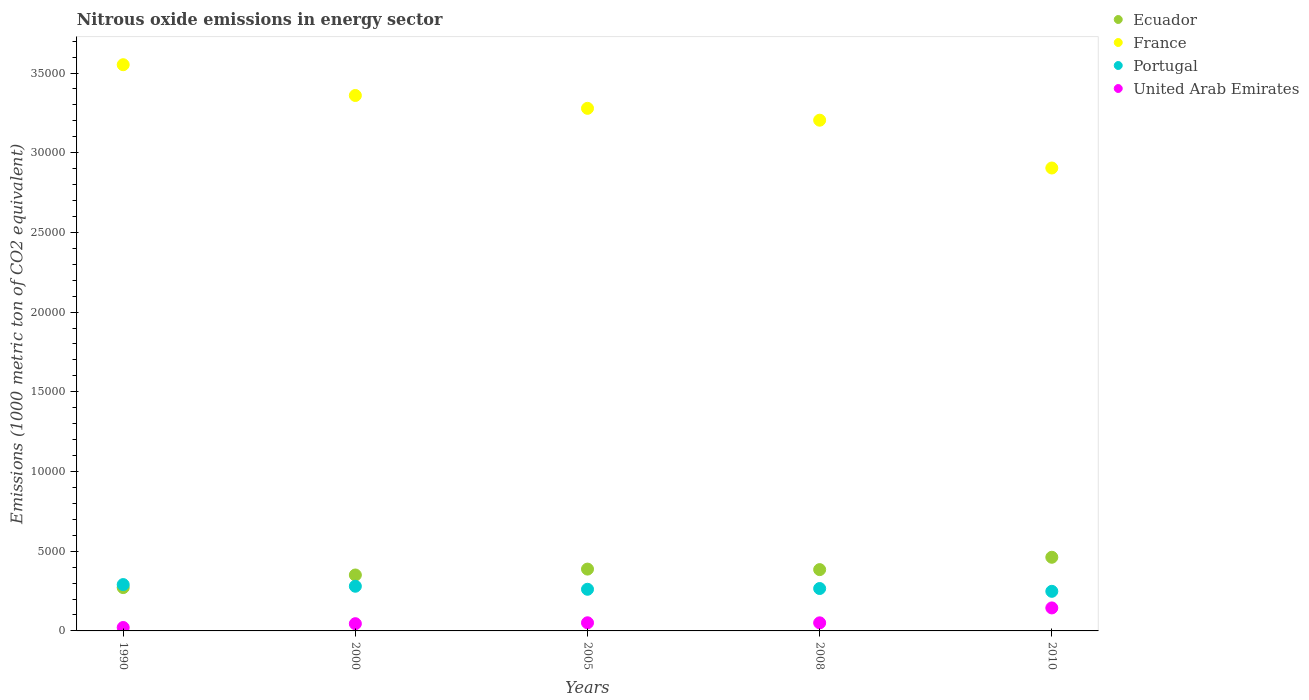What is the amount of nitrous oxide emitted in Ecuador in 2000?
Your answer should be compact. 3508.3. Across all years, what is the maximum amount of nitrous oxide emitted in Ecuador?
Offer a very short reply. 4620.6. Across all years, what is the minimum amount of nitrous oxide emitted in Ecuador?
Give a very brief answer. 2718.5. In which year was the amount of nitrous oxide emitted in France maximum?
Give a very brief answer. 1990. In which year was the amount of nitrous oxide emitted in Ecuador minimum?
Offer a terse response. 1990. What is the total amount of nitrous oxide emitted in France in the graph?
Your answer should be compact. 1.63e+05. What is the difference between the amount of nitrous oxide emitted in United Arab Emirates in 2005 and that in 2008?
Give a very brief answer. 2.5. What is the difference between the amount of nitrous oxide emitted in United Arab Emirates in 2000 and the amount of nitrous oxide emitted in France in 2008?
Provide a short and direct response. -3.16e+04. What is the average amount of nitrous oxide emitted in United Arab Emirates per year?
Offer a very short reply. 625.74. In the year 2005, what is the difference between the amount of nitrous oxide emitted in France and amount of nitrous oxide emitted in United Arab Emirates?
Make the answer very short. 3.23e+04. In how many years, is the amount of nitrous oxide emitted in Portugal greater than 5000 1000 metric ton?
Give a very brief answer. 0. What is the ratio of the amount of nitrous oxide emitted in France in 2005 to that in 2010?
Your answer should be compact. 1.13. What is the difference between the highest and the second highest amount of nitrous oxide emitted in Ecuador?
Your answer should be very brief. 742.1. What is the difference between the highest and the lowest amount of nitrous oxide emitted in Ecuador?
Give a very brief answer. 1902.1. Does the amount of nitrous oxide emitted in Ecuador monotonically increase over the years?
Keep it short and to the point. No. Is the amount of nitrous oxide emitted in Portugal strictly less than the amount of nitrous oxide emitted in United Arab Emirates over the years?
Your response must be concise. No. How many years are there in the graph?
Make the answer very short. 5. What is the difference between two consecutive major ticks on the Y-axis?
Give a very brief answer. 5000. Are the values on the major ticks of Y-axis written in scientific E-notation?
Keep it short and to the point. No. Does the graph contain any zero values?
Give a very brief answer. No. Does the graph contain grids?
Keep it short and to the point. No. Where does the legend appear in the graph?
Ensure brevity in your answer.  Top right. What is the title of the graph?
Give a very brief answer. Nitrous oxide emissions in energy sector. What is the label or title of the X-axis?
Ensure brevity in your answer.  Years. What is the label or title of the Y-axis?
Your answer should be compact. Emissions (1000 metric ton of CO2 equivalent). What is the Emissions (1000 metric ton of CO2 equivalent) in Ecuador in 1990?
Your answer should be compact. 2718.5. What is the Emissions (1000 metric ton of CO2 equivalent) in France in 1990?
Keep it short and to the point. 3.55e+04. What is the Emissions (1000 metric ton of CO2 equivalent) of Portugal in 1990?
Provide a succinct answer. 2907.5. What is the Emissions (1000 metric ton of CO2 equivalent) of United Arab Emirates in 1990?
Your answer should be very brief. 214.5. What is the Emissions (1000 metric ton of CO2 equivalent) of Ecuador in 2000?
Offer a terse response. 3508.3. What is the Emissions (1000 metric ton of CO2 equivalent) in France in 2000?
Ensure brevity in your answer.  3.36e+04. What is the Emissions (1000 metric ton of CO2 equivalent) of Portugal in 2000?
Offer a very short reply. 2802.4. What is the Emissions (1000 metric ton of CO2 equivalent) of United Arab Emirates in 2000?
Provide a short and direct response. 453.6. What is the Emissions (1000 metric ton of CO2 equivalent) in Ecuador in 2005?
Offer a terse response. 3878.5. What is the Emissions (1000 metric ton of CO2 equivalent) in France in 2005?
Keep it short and to the point. 3.28e+04. What is the Emissions (1000 metric ton of CO2 equivalent) of Portugal in 2005?
Make the answer very short. 2612.4. What is the Emissions (1000 metric ton of CO2 equivalent) in United Arab Emirates in 2005?
Keep it short and to the point. 510.2. What is the Emissions (1000 metric ton of CO2 equivalent) in Ecuador in 2008?
Your answer should be compact. 3846. What is the Emissions (1000 metric ton of CO2 equivalent) in France in 2008?
Give a very brief answer. 3.20e+04. What is the Emissions (1000 metric ton of CO2 equivalent) of Portugal in 2008?
Make the answer very short. 2660.2. What is the Emissions (1000 metric ton of CO2 equivalent) of United Arab Emirates in 2008?
Offer a very short reply. 507.7. What is the Emissions (1000 metric ton of CO2 equivalent) of Ecuador in 2010?
Make the answer very short. 4620.6. What is the Emissions (1000 metric ton of CO2 equivalent) of France in 2010?
Offer a very short reply. 2.90e+04. What is the Emissions (1000 metric ton of CO2 equivalent) of Portugal in 2010?
Provide a succinct answer. 2484. What is the Emissions (1000 metric ton of CO2 equivalent) of United Arab Emirates in 2010?
Provide a succinct answer. 1442.7. Across all years, what is the maximum Emissions (1000 metric ton of CO2 equivalent) of Ecuador?
Keep it short and to the point. 4620.6. Across all years, what is the maximum Emissions (1000 metric ton of CO2 equivalent) of France?
Give a very brief answer. 3.55e+04. Across all years, what is the maximum Emissions (1000 metric ton of CO2 equivalent) in Portugal?
Your response must be concise. 2907.5. Across all years, what is the maximum Emissions (1000 metric ton of CO2 equivalent) of United Arab Emirates?
Make the answer very short. 1442.7. Across all years, what is the minimum Emissions (1000 metric ton of CO2 equivalent) of Ecuador?
Keep it short and to the point. 2718.5. Across all years, what is the minimum Emissions (1000 metric ton of CO2 equivalent) of France?
Your answer should be very brief. 2.90e+04. Across all years, what is the minimum Emissions (1000 metric ton of CO2 equivalent) of Portugal?
Your answer should be compact. 2484. Across all years, what is the minimum Emissions (1000 metric ton of CO2 equivalent) of United Arab Emirates?
Give a very brief answer. 214.5. What is the total Emissions (1000 metric ton of CO2 equivalent) of Ecuador in the graph?
Provide a succinct answer. 1.86e+04. What is the total Emissions (1000 metric ton of CO2 equivalent) of France in the graph?
Offer a very short reply. 1.63e+05. What is the total Emissions (1000 metric ton of CO2 equivalent) of Portugal in the graph?
Offer a very short reply. 1.35e+04. What is the total Emissions (1000 metric ton of CO2 equivalent) in United Arab Emirates in the graph?
Give a very brief answer. 3128.7. What is the difference between the Emissions (1000 metric ton of CO2 equivalent) of Ecuador in 1990 and that in 2000?
Your answer should be compact. -789.8. What is the difference between the Emissions (1000 metric ton of CO2 equivalent) in France in 1990 and that in 2000?
Keep it short and to the point. 1930.3. What is the difference between the Emissions (1000 metric ton of CO2 equivalent) in Portugal in 1990 and that in 2000?
Provide a short and direct response. 105.1. What is the difference between the Emissions (1000 metric ton of CO2 equivalent) of United Arab Emirates in 1990 and that in 2000?
Your answer should be very brief. -239.1. What is the difference between the Emissions (1000 metric ton of CO2 equivalent) of Ecuador in 1990 and that in 2005?
Ensure brevity in your answer.  -1160. What is the difference between the Emissions (1000 metric ton of CO2 equivalent) of France in 1990 and that in 2005?
Keep it short and to the point. 2736.8. What is the difference between the Emissions (1000 metric ton of CO2 equivalent) of Portugal in 1990 and that in 2005?
Offer a very short reply. 295.1. What is the difference between the Emissions (1000 metric ton of CO2 equivalent) of United Arab Emirates in 1990 and that in 2005?
Make the answer very short. -295.7. What is the difference between the Emissions (1000 metric ton of CO2 equivalent) in Ecuador in 1990 and that in 2008?
Your answer should be very brief. -1127.5. What is the difference between the Emissions (1000 metric ton of CO2 equivalent) of France in 1990 and that in 2008?
Make the answer very short. 3480.3. What is the difference between the Emissions (1000 metric ton of CO2 equivalent) of Portugal in 1990 and that in 2008?
Your answer should be compact. 247.3. What is the difference between the Emissions (1000 metric ton of CO2 equivalent) in United Arab Emirates in 1990 and that in 2008?
Provide a succinct answer. -293.2. What is the difference between the Emissions (1000 metric ton of CO2 equivalent) in Ecuador in 1990 and that in 2010?
Offer a very short reply. -1902.1. What is the difference between the Emissions (1000 metric ton of CO2 equivalent) in France in 1990 and that in 2010?
Your response must be concise. 6479.5. What is the difference between the Emissions (1000 metric ton of CO2 equivalent) in Portugal in 1990 and that in 2010?
Your answer should be compact. 423.5. What is the difference between the Emissions (1000 metric ton of CO2 equivalent) in United Arab Emirates in 1990 and that in 2010?
Provide a succinct answer. -1228.2. What is the difference between the Emissions (1000 metric ton of CO2 equivalent) in Ecuador in 2000 and that in 2005?
Keep it short and to the point. -370.2. What is the difference between the Emissions (1000 metric ton of CO2 equivalent) of France in 2000 and that in 2005?
Offer a very short reply. 806.5. What is the difference between the Emissions (1000 metric ton of CO2 equivalent) of Portugal in 2000 and that in 2005?
Offer a terse response. 190. What is the difference between the Emissions (1000 metric ton of CO2 equivalent) of United Arab Emirates in 2000 and that in 2005?
Keep it short and to the point. -56.6. What is the difference between the Emissions (1000 metric ton of CO2 equivalent) in Ecuador in 2000 and that in 2008?
Provide a succinct answer. -337.7. What is the difference between the Emissions (1000 metric ton of CO2 equivalent) of France in 2000 and that in 2008?
Your answer should be very brief. 1550. What is the difference between the Emissions (1000 metric ton of CO2 equivalent) of Portugal in 2000 and that in 2008?
Make the answer very short. 142.2. What is the difference between the Emissions (1000 metric ton of CO2 equivalent) in United Arab Emirates in 2000 and that in 2008?
Your answer should be very brief. -54.1. What is the difference between the Emissions (1000 metric ton of CO2 equivalent) in Ecuador in 2000 and that in 2010?
Provide a succinct answer. -1112.3. What is the difference between the Emissions (1000 metric ton of CO2 equivalent) of France in 2000 and that in 2010?
Make the answer very short. 4549.2. What is the difference between the Emissions (1000 metric ton of CO2 equivalent) of Portugal in 2000 and that in 2010?
Provide a succinct answer. 318.4. What is the difference between the Emissions (1000 metric ton of CO2 equivalent) in United Arab Emirates in 2000 and that in 2010?
Provide a succinct answer. -989.1. What is the difference between the Emissions (1000 metric ton of CO2 equivalent) of Ecuador in 2005 and that in 2008?
Your answer should be very brief. 32.5. What is the difference between the Emissions (1000 metric ton of CO2 equivalent) in France in 2005 and that in 2008?
Give a very brief answer. 743.5. What is the difference between the Emissions (1000 metric ton of CO2 equivalent) of Portugal in 2005 and that in 2008?
Make the answer very short. -47.8. What is the difference between the Emissions (1000 metric ton of CO2 equivalent) in Ecuador in 2005 and that in 2010?
Make the answer very short. -742.1. What is the difference between the Emissions (1000 metric ton of CO2 equivalent) of France in 2005 and that in 2010?
Provide a succinct answer. 3742.7. What is the difference between the Emissions (1000 metric ton of CO2 equivalent) in Portugal in 2005 and that in 2010?
Provide a succinct answer. 128.4. What is the difference between the Emissions (1000 metric ton of CO2 equivalent) of United Arab Emirates in 2005 and that in 2010?
Make the answer very short. -932.5. What is the difference between the Emissions (1000 metric ton of CO2 equivalent) of Ecuador in 2008 and that in 2010?
Offer a terse response. -774.6. What is the difference between the Emissions (1000 metric ton of CO2 equivalent) in France in 2008 and that in 2010?
Your answer should be very brief. 2999.2. What is the difference between the Emissions (1000 metric ton of CO2 equivalent) in Portugal in 2008 and that in 2010?
Ensure brevity in your answer.  176.2. What is the difference between the Emissions (1000 metric ton of CO2 equivalent) of United Arab Emirates in 2008 and that in 2010?
Provide a short and direct response. -935. What is the difference between the Emissions (1000 metric ton of CO2 equivalent) in Ecuador in 1990 and the Emissions (1000 metric ton of CO2 equivalent) in France in 2000?
Give a very brief answer. -3.09e+04. What is the difference between the Emissions (1000 metric ton of CO2 equivalent) in Ecuador in 1990 and the Emissions (1000 metric ton of CO2 equivalent) in Portugal in 2000?
Your answer should be very brief. -83.9. What is the difference between the Emissions (1000 metric ton of CO2 equivalent) of Ecuador in 1990 and the Emissions (1000 metric ton of CO2 equivalent) of United Arab Emirates in 2000?
Your answer should be very brief. 2264.9. What is the difference between the Emissions (1000 metric ton of CO2 equivalent) in France in 1990 and the Emissions (1000 metric ton of CO2 equivalent) in Portugal in 2000?
Your response must be concise. 3.27e+04. What is the difference between the Emissions (1000 metric ton of CO2 equivalent) in France in 1990 and the Emissions (1000 metric ton of CO2 equivalent) in United Arab Emirates in 2000?
Provide a short and direct response. 3.51e+04. What is the difference between the Emissions (1000 metric ton of CO2 equivalent) of Portugal in 1990 and the Emissions (1000 metric ton of CO2 equivalent) of United Arab Emirates in 2000?
Provide a succinct answer. 2453.9. What is the difference between the Emissions (1000 metric ton of CO2 equivalent) of Ecuador in 1990 and the Emissions (1000 metric ton of CO2 equivalent) of France in 2005?
Keep it short and to the point. -3.01e+04. What is the difference between the Emissions (1000 metric ton of CO2 equivalent) of Ecuador in 1990 and the Emissions (1000 metric ton of CO2 equivalent) of Portugal in 2005?
Offer a very short reply. 106.1. What is the difference between the Emissions (1000 metric ton of CO2 equivalent) of Ecuador in 1990 and the Emissions (1000 metric ton of CO2 equivalent) of United Arab Emirates in 2005?
Provide a short and direct response. 2208.3. What is the difference between the Emissions (1000 metric ton of CO2 equivalent) in France in 1990 and the Emissions (1000 metric ton of CO2 equivalent) in Portugal in 2005?
Offer a very short reply. 3.29e+04. What is the difference between the Emissions (1000 metric ton of CO2 equivalent) in France in 1990 and the Emissions (1000 metric ton of CO2 equivalent) in United Arab Emirates in 2005?
Offer a terse response. 3.50e+04. What is the difference between the Emissions (1000 metric ton of CO2 equivalent) of Portugal in 1990 and the Emissions (1000 metric ton of CO2 equivalent) of United Arab Emirates in 2005?
Give a very brief answer. 2397.3. What is the difference between the Emissions (1000 metric ton of CO2 equivalent) of Ecuador in 1990 and the Emissions (1000 metric ton of CO2 equivalent) of France in 2008?
Provide a succinct answer. -2.93e+04. What is the difference between the Emissions (1000 metric ton of CO2 equivalent) in Ecuador in 1990 and the Emissions (1000 metric ton of CO2 equivalent) in Portugal in 2008?
Offer a very short reply. 58.3. What is the difference between the Emissions (1000 metric ton of CO2 equivalent) in Ecuador in 1990 and the Emissions (1000 metric ton of CO2 equivalent) in United Arab Emirates in 2008?
Make the answer very short. 2210.8. What is the difference between the Emissions (1000 metric ton of CO2 equivalent) in France in 1990 and the Emissions (1000 metric ton of CO2 equivalent) in Portugal in 2008?
Your answer should be very brief. 3.29e+04. What is the difference between the Emissions (1000 metric ton of CO2 equivalent) in France in 1990 and the Emissions (1000 metric ton of CO2 equivalent) in United Arab Emirates in 2008?
Your answer should be compact. 3.50e+04. What is the difference between the Emissions (1000 metric ton of CO2 equivalent) in Portugal in 1990 and the Emissions (1000 metric ton of CO2 equivalent) in United Arab Emirates in 2008?
Your response must be concise. 2399.8. What is the difference between the Emissions (1000 metric ton of CO2 equivalent) in Ecuador in 1990 and the Emissions (1000 metric ton of CO2 equivalent) in France in 2010?
Give a very brief answer. -2.63e+04. What is the difference between the Emissions (1000 metric ton of CO2 equivalent) in Ecuador in 1990 and the Emissions (1000 metric ton of CO2 equivalent) in Portugal in 2010?
Provide a short and direct response. 234.5. What is the difference between the Emissions (1000 metric ton of CO2 equivalent) of Ecuador in 1990 and the Emissions (1000 metric ton of CO2 equivalent) of United Arab Emirates in 2010?
Offer a terse response. 1275.8. What is the difference between the Emissions (1000 metric ton of CO2 equivalent) of France in 1990 and the Emissions (1000 metric ton of CO2 equivalent) of Portugal in 2010?
Provide a short and direct response. 3.30e+04. What is the difference between the Emissions (1000 metric ton of CO2 equivalent) in France in 1990 and the Emissions (1000 metric ton of CO2 equivalent) in United Arab Emirates in 2010?
Offer a terse response. 3.41e+04. What is the difference between the Emissions (1000 metric ton of CO2 equivalent) in Portugal in 1990 and the Emissions (1000 metric ton of CO2 equivalent) in United Arab Emirates in 2010?
Ensure brevity in your answer.  1464.8. What is the difference between the Emissions (1000 metric ton of CO2 equivalent) in Ecuador in 2000 and the Emissions (1000 metric ton of CO2 equivalent) in France in 2005?
Offer a terse response. -2.93e+04. What is the difference between the Emissions (1000 metric ton of CO2 equivalent) in Ecuador in 2000 and the Emissions (1000 metric ton of CO2 equivalent) in Portugal in 2005?
Your answer should be very brief. 895.9. What is the difference between the Emissions (1000 metric ton of CO2 equivalent) in Ecuador in 2000 and the Emissions (1000 metric ton of CO2 equivalent) in United Arab Emirates in 2005?
Provide a short and direct response. 2998.1. What is the difference between the Emissions (1000 metric ton of CO2 equivalent) of France in 2000 and the Emissions (1000 metric ton of CO2 equivalent) of Portugal in 2005?
Make the answer very short. 3.10e+04. What is the difference between the Emissions (1000 metric ton of CO2 equivalent) in France in 2000 and the Emissions (1000 metric ton of CO2 equivalent) in United Arab Emirates in 2005?
Provide a succinct answer. 3.31e+04. What is the difference between the Emissions (1000 metric ton of CO2 equivalent) of Portugal in 2000 and the Emissions (1000 metric ton of CO2 equivalent) of United Arab Emirates in 2005?
Give a very brief answer. 2292.2. What is the difference between the Emissions (1000 metric ton of CO2 equivalent) in Ecuador in 2000 and the Emissions (1000 metric ton of CO2 equivalent) in France in 2008?
Your answer should be compact. -2.85e+04. What is the difference between the Emissions (1000 metric ton of CO2 equivalent) of Ecuador in 2000 and the Emissions (1000 metric ton of CO2 equivalent) of Portugal in 2008?
Offer a very short reply. 848.1. What is the difference between the Emissions (1000 metric ton of CO2 equivalent) in Ecuador in 2000 and the Emissions (1000 metric ton of CO2 equivalent) in United Arab Emirates in 2008?
Your response must be concise. 3000.6. What is the difference between the Emissions (1000 metric ton of CO2 equivalent) of France in 2000 and the Emissions (1000 metric ton of CO2 equivalent) of Portugal in 2008?
Your answer should be compact. 3.09e+04. What is the difference between the Emissions (1000 metric ton of CO2 equivalent) in France in 2000 and the Emissions (1000 metric ton of CO2 equivalent) in United Arab Emirates in 2008?
Offer a very short reply. 3.31e+04. What is the difference between the Emissions (1000 metric ton of CO2 equivalent) in Portugal in 2000 and the Emissions (1000 metric ton of CO2 equivalent) in United Arab Emirates in 2008?
Your response must be concise. 2294.7. What is the difference between the Emissions (1000 metric ton of CO2 equivalent) in Ecuador in 2000 and the Emissions (1000 metric ton of CO2 equivalent) in France in 2010?
Give a very brief answer. -2.55e+04. What is the difference between the Emissions (1000 metric ton of CO2 equivalent) in Ecuador in 2000 and the Emissions (1000 metric ton of CO2 equivalent) in Portugal in 2010?
Ensure brevity in your answer.  1024.3. What is the difference between the Emissions (1000 metric ton of CO2 equivalent) in Ecuador in 2000 and the Emissions (1000 metric ton of CO2 equivalent) in United Arab Emirates in 2010?
Keep it short and to the point. 2065.6. What is the difference between the Emissions (1000 metric ton of CO2 equivalent) in France in 2000 and the Emissions (1000 metric ton of CO2 equivalent) in Portugal in 2010?
Make the answer very short. 3.11e+04. What is the difference between the Emissions (1000 metric ton of CO2 equivalent) of France in 2000 and the Emissions (1000 metric ton of CO2 equivalent) of United Arab Emirates in 2010?
Provide a short and direct response. 3.21e+04. What is the difference between the Emissions (1000 metric ton of CO2 equivalent) in Portugal in 2000 and the Emissions (1000 metric ton of CO2 equivalent) in United Arab Emirates in 2010?
Provide a succinct answer. 1359.7. What is the difference between the Emissions (1000 metric ton of CO2 equivalent) of Ecuador in 2005 and the Emissions (1000 metric ton of CO2 equivalent) of France in 2008?
Your answer should be very brief. -2.82e+04. What is the difference between the Emissions (1000 metric ton of CO2 equivalent) in Ecuador in 2005 and the Emissions (1000 metric ton of CO2 equivalent) in Portugal in 2008?
Provide a succinct answer. 1218.3. What is the difference between the Emissions (1000 metric ton of CO2 equivalent) in Ecuador in 2005 and the Emissions (1000 metric ton of CO2 equivalent) in United Arab Emirates in 2008?
Keep it short and to the point. 3370.8. What is the difference between the Emissions (1000 metric ton of CO2 equivalent) of France in 2005 and the Emissions (1000 metric ton of CO2 equivalent) of Portugal in 2008?
Offer a terse response. 3.01e+04. What is the difference between the Emissions (1000 metric ton of CO2 equivalent) in France in 2005 and the Emissions (1000 metric ton of CO2 equivalent) in United Arab Emirates in 2008?
Provide a short and direct response. 3.23e+04. What is the difference between the Emissions (1000 metric ton of CO2 equivalent) in Portugal in 2005 and the Emissions (1000 metric ton of CO2 equivalent) in United Arab Emirates in 2008?
Your answer should be very brief. 2104.7. What is the difference between the Emissions (1000 metric ton of CO2 equivalent) of Ecuador in 2005 and the Emissions (1000 metric ton of CO2 equivalent) of France in 2010?
Your answer should be compact. -2.52e+04. What is the difference between the Emissions (1000 metric ton of CO2 equivalent) in Ecuador in 2005 and the Emissions (1000 metric ton of CO2 equivalent) in Portugal in 2010?
Make the answer very short. 1394.5. What is the difference between the Emissions (1000 metric ton of CO2 equivalent) in Ecuador in 2005 and the Emissions (1000 metric ton of CO2 equivalent) in United Arab Emirates in 2010?
Your response must be concise. 2435.8. What is the difference between the Emissions (1000 metric ton of CO2 equivalent) in France in 2005 and the Emissions (1000 metric ton of CO2 equivalent) in Portugal in 2010?
Make the answer very short. 3.03e+04. What is the difference between the Emissions (1000 metric ton of CO2 equivalent) of France in 2005 and the Emissions (1000 metric ton of CO2 equivalent) of United Arab Emirates in 2010?
Offer a terse response. 3.13e+04. What is the difference between the Emissions (1000 metric ton of CO2 equivalent) of Portugal in 2005 and the Emissions (1000 metric ton of CO2 equivalent) of United Arab Emirates in 2010?
Provide a succinct answer. 1169.7. What is the difference between the Emissions (1000 metric ton of CO2 equivalent) in Ecuador in 2008 and the Emissions (1000 metric ton of CO2 equivalent) in France in 2010?
Offer a very short reply. -2.52e+04. What is the difference between the Emissions (1000 metric ton of CO2 equivalent) in Ecuador in 2008 and the Emissions (1000 metric ton of CO2 equivalent) in Portugal in 2010?
Keep it short and to the point. 1362. What is the difference between the Emissions (1000 metric ton of CO2 equivalent) in Ecuador in 2008 and the Emissions (1000 metric ton of CO2 equivalent) in United Arab Emirates in 2010?
Provide a short and direct response. 2403.3. What is the difference between the Emissions (1000 metric ton of CO2 equivalent) in France in 2008 and the Emissions (1000 metric ton of CO2 equivalent) in Portugal in 2010?
Your answer should be very brief. 2.96e+04. What is the difference between the Emissions (1000 metric ton of CO2 equivalent) of France in 2008 and the Emissions (1000 metric ton of CO2 equivalent) of United Arab Emirates in 2010?
Your response must be concise. 3.06e+04. What is the difference between the Emissions (1000 metric ton of CO2 equivalent) of Portugal in 2008 and the Emissions (1000 metric ton of CO2 equivalent) of United Arab Emirates in 2010?
Give a very brief answer. 1217.5. What is the average Emissions (1000 metric ton of CO2 equivalent) of Ecuador per year?
Offer a terse response. 3714.38. What is the average Emissions (1000 metric ton of CO2 equivalent) in France per year?
Give a very brief answer. 3.26e+04. What is the average Emissions (1000 metric ton of CO2 equivalent) in Portugal per year?
Your response must be concise. 2693.3. What is the average Emissions (1000 metric ton of CO2 equivalent) in United Arab Emirates per year?
Make the answer very short. 625.74. In the year 1990, what is the difference between the Emissions (1000 metric ton of CO2 equivalent) of Ecuador and Emissions (1000 metric ton of CO2 equivalent) of France?
Offer a very short reply. -3.28e+04. In the year 1990, what is the difference between the Emissions (1000 metric ton of CO2 equivalent) in Ecuador and Emissions (1000 metric ton of CO2 equivalent) in Portugal?
Offer a terse response. -189. In the year 1990, what is the difference between the Emissions (1000 metric ton of CO2 equivalent) in Ecuador and Emissions (1000 metric ton of CO2 equivalent) in United Arab Emirates?
Provide a succinct answer. 2504. In the year 1990, what is the difference between the Emissions (1000 metric ton of CO2 equivalent) in France and Emissions (1000 metric ton of CO2 equivalent) in Portugal?
Provide a succinct answer. 3.26e+04. In the year 1990, what is the difference between the Emissions (1000 metric ton of CO2 equivalent) in France and Emissions (1000 metric ton of CO2 equivalent) in United Arab Emirates?
Ensure brevity in your answer.  3.53e+04. In the year 1990, what is the difference between the Emissions (1000 metric ton of CO2 equivalent) in Portugal and Emissions (1000 metric ton of CO2 equivalent) in United Arab Emirates?
Keep it short and to the point. 2693. In the year 2000, what is the difference between the Emissions (1000 metric ton of CO2 equivalent) of Ecuador and Emissions (1000 metric ton of CO2 equivalent) of France?
Provide a short and direct response. -3.01e+04. In the year 2000, what is the difference between the Emissions (1000 metric ton of CO2 equivalent) in Ecuador and Emissions (1000 metric ton of CO2 equivalent) in Portugal?
Make the answer very short. 705.9. In the year 2000, what is the difference between the Emissions (1000 metric ton of CO2 equivalent) in Ecuador and Emissions (1000 metric ton of CO2 equivalent) in United Arab Emirates?
Ensure brevity in your answer.  3054.7. In the year 2000, what is the difference between the Emissions (1000 metric ton of CO2 equivalent) in France and Emissions (1000 metric ton of CO2 equivalent) in Portugal?
Keep it short and to the point. 3.08e+04. In the year 2000, what is the difference between the Emissions (1000 metric ton of CO2 equivalent) in France and Emissions (1000 metric ton of CO2 equivalent) in United Arab Emirates?
Your response must be concise. 3.31e+04. In the year 2000, what is the difference between the Emissions (1000 metric ton of CO2 equivalent) in Portugal and Emissions (1000 metric ton of CO2 equivalent) in United Arab Emirates?
Give a very brief answer. 2348.8. In the year 2005, what is the difference between the Emissions (1000 metric ton of CO2 equivalent) of Ecuador and Emissions (1000 metric ton of CO2 equivalent) of France?
Provide a succinct answer. -2.89e+04. In the year 2005, what is the difference between the Emissions (1000 metric ton of CO2 equivalent) of Ecuador and Emissions (1000 metric ton of CO2 equivalent) of Portugal?
Offer a terse response. 1266.1. In the year 2005, what is the difference between the Emissions (1000 metric ton of CO2 equivalent) of Ecuador and Emissions (1000 metric ton of CO2 equivalent) of United Arab Emirates?
Your answer should be compact. 3368.3. In the year 2005, what is the difference between the Emissions (1000 metric ton of CO2 equivalent) in France and Emissions (1000 metric ton of CO2 equivalent) in Portugal?
Offer a terse response. 3.02e+04. In the year 2005, what is the difference between the Emissions (1000 metric ton of CO2 equivalent) in France and Emissions (1000 metric ton of CO2 equivalent) in United Arab Emirates?
Your answer should be compact. 3.23e+04. In the year 2005, what is the difference between the Emissions (1000 metric ton of CO2 equivalent) of Portugal and Emissions (1000 metric ton of CO2 equivalent) of United Arab Emirates?
Keep it short and to the point. 2102.2. In the year 2008, what is the difference between the Emissions (1000 metric ton of CO2 equivalent) of Ecuador and Emissions (1000 metric ton of CO2 equivalent) of France?
Offer a very short reply. -2.82e+04. In the year 2008, what is the difference between the Emissions (1000 metric ton of CO2 equivalent) in Ecuador and Emissions (1000 metric ton of CO2 equivalent) in Portugal?
Offer a terse response. 1185.8. In the year 2008, what is the difference between the Emissions (1000 metric ton of CO2 equivalent) of Ecuador and Emissions (1000 metric ton of CO2 equivalent) of United Arab Emirates?
Make the answer very short. 3338.3. In the year 2008, what is the difference between the Emissions (1000 metric ton of CO2 equivalent) in France and Emissions (1000 metric ton of CO2 equivalent) in Portugal?
Your response must be concise. 2.94e+04. In the year 2008, what is the difference between the Emissions (1000 metric ton of CO2 equivalent) in France and Emissions (1000 metric ton of CO2 equivalent) in United Arab Emirates?
Give a very brief answer. 3.15e+04. In the year 2008, what is the difference between the Emissions (1000 metric ton of CO2 equivalent) of Portugal and Emissions (1000 metric ton of CO2 equivalent) of United Arab Emirates?
Your response must be concise. 2152.5. In the year 2010, what is the difference between the Emissions (1000 metric ton of CO2 equivalent) of Ecuador and Emissions (1000 metric ton of CO2 equivalent) of France?
Provide a short and direct response. -2.44e+04. In the year 2010, what is the difference between the Emissions (1000 metric ton of CO2 equivalent) in Ecuador and Emissions (1000 metric ton of CO2 equivalent) in Portugal?
Ensure brevity in your answer.  2136.6. In the year 2010, what is the difference between the Emissions (1000 metric ton of CO2 equivalent) in Ecuador and Emissions (1000 metric ton of CO2 equivalent) in United Arab Emirates?
Give a very brief answer. 3177.9. In the year 2010, what is the difference between the Emissions (1000 metric ton of CO2 equivalent) of France and Emissions (1000 metric ton of CO2 equivalent) of Portugal?
Your answer should be very brief. 2.66e+04. In the year 2010, what is the difference between the Emissions (1000 metric ton of CO2 equivalent) of France and Emissions (1000 metric ton of CO2 equivalent) of United Arab Emirates?
Your response must be concise. 2.76e+04. In the year 2010, what is the difference between the Emissions (1000 metric ton of CO2 equivalent) of Portugal and Emissions (1000 metric ton of CO2 equivalent) of United Arab Emirates?
Provide a succinct answer. 1041.3. What is the ratio of the Emissions (1000 metric ton of CO2 equivalent) of Ecuador in 1990 to that in 2000?
Ensure brevity in your answer.  0.77. What is the ratio of the Emissions (1000 metric ton of CO2 equivalent) in France in 1990 to that in 2000?
Give a very brief answer. 1.06. What is the ratio of the Emissions (1000 metric ton of CO2 equivalent) of Portugal in 1990 to that in 2000?
Ensure brevity in your answer.  1.04. What is the ratio of the Emissions (1000 metric ton of CO2 equivalent) of United Arab Emirates in 1990 to that in 2000?
Make the answer very short. 0.47. What is the ratio of the Emissions (1000 metric ton of CO2 equivalent) of Ecuador in 1990 to that in 2005?
Your answer should be very brief. 0.7. What is the ratio of the Emissions (1000 metric ton of CO2 equivalent) of France in 1990 to that in 2005?
Your answer should be compact. 1.08. What is the ratio of the Emissions (1000 metric ton of CO2 equivalent) of Portugal in 1990 to that in 2005?
Your answer should be very brief. 1.11. What is the ratio of the Emissions (1000 metric ton of CO2 equivalent) of United Arab Emirates in 1990 to that in 2005?
Ensure brevity in your answer.  0.42. What is the ratio of the Emissions (1000 metric ton of CO2 equivalent) in Ecuador in 1990 to that in 2008?
Make the answer very short. 0.71. What is the ratio of the Emissions (1000 metric ton of CO2 equivalent) in France in 1990 to that in 2008?
Provide a short and direct response. 1.11. What is the ratio of the Emissions (1000 metric ton of CO2 equivalent) of Portugal in 1990 to that in 2008?
Ensure brevity in your answer.  1.09. What is the ratio of the Emissions (1000 metric ton of CO2 equivalent) of United Arab Emirates in 1990 to that in 2008?
Offer a very short reply. 0.42. What is the ratio of the Emissions (1000 metric ton of CO2 equivalent) in Ecuador in 1990 to that in 2010?
Your response must be concise. 0.59. What is the ratio of the Emissions (1000 metric ton of CO2 equivalent) of France in 1990 to that in 2010?
Provide a succinct answer. 1.22. What is the ratio of the Emissions (1000 metric ton of CO2 equivalent) of Portugal in 1990 to that in 2010?
Provide a succinct answer. 1.17. What is the ratio of the Emissions (1000 metric ton of CO2 equivalent) in United Arab Emirates in 1990 to that in 2010?
Provide a short and direct response. 0.15. What is the ratio of the Emissions (1000 metric ton of CO2 equivalent) in Ecuador in 2000 to that in 2005?
Provide a short and direct response. 0.9. What is the ratio of the Emissions (1000 metric ton of CO2 equivalent) of France in 2000 to that in 2005?
Your answer should be very brief. 1.02. What is the ratio of the Emissions (1000 metric ton of CO2 equivalent) of Portugal in 2000 to that in 2005?
Offer a very short reply. 1.07. What is the ratio of the Emissions (1000 metric ton of CO2 equivalent) of United Arab Emirates in 2000 to that in 2005?
Ensure brevity in your answer.  0.89. What is the ratio of the Emissions (1000 metric ton of CO2 equivalent) of Ecuador in 2000 to that in 2008?
Offer a very short reply. 0.91. What is the ratio of the Emissions (1000 metric ton of CO2 equivalent) of France in 2000 to that in 2008?
Give a very brief answer. 1.05. What is the ratio of the Emissions (1000 metric ton of CO2 equivalent) of Portugal in 2000 to that in 2008?
Offer a terse response. 1.05. What is the ratio of the Emissions (1000 metric ton of CO2 equivalent) in United Arab Emirates in 2000 to that in 2008?
Make the answer very short. 0.89. What is the ratio of the Emissions (1000 metric ton of CO2 equivalent) of Ecuador in 2000 to that in 2010?
Give a very brief answer. 0.76. What is the ratio of the Emissions (1000 metric ton of CO2 equivalent) of France in 2000 to that in 2010?
Give a very brief answer. 1.16. What is the ratio of the Emissions (1000 metric ton of CO2 equivalent) of Portugal in 2000 to that in 2010?
Provide a succinct answer. 1.13. What is the ratio of the Emissions (1000 metric ton of CO2 equivalent) of United Arab Emirates in 2000 to that in 2010?
Provide a short and direct response. 0.31. What is the ratio of the Emissions (1000 metric ton of CO2 equivalent) in Ecuador in 2005 to that in 2008?
Offer a very short reply. 1.01. What is the ratio of the Emissions (1000 metric ton of CO2 equivalent) of France in 2005 to that in 2008?
Keep it short and to the point. 1.02. What is the ratio of the Emissions (1000 metric ton of CO2 equivalent) of United Arab Emirates in 2005 to that in 2008?
Offer a terse response. 1. What is the ratio of the Emissions (1000 metric ton of CO2 equivalent) of Ecuador in 2005 to that in 2010?
Provide a succinct answer. 0.84. What is the ratio of the Emissions (1000 metric ton of CO2 equivalent) in France in 2005 to that in 2010?
Give a very brief answer. 1.13. What is the ratio of the Emissions (1000 metric ton of CO2 equivalent) of Portugal in 2005 to that in 2010?
Give a very brief answer. 1.05. What is the ratio of the Emissions (1000 metric ton of CO2 equivalent) in United Arab Emirates in 2005 to that in 2010?
Offer a terse response. 0.35. What is the ratio of the Emissions (1000 metric ton of CO2 equivalent) in Ecuador in 2008 to that in 2010?
Your response must be concise. 0.83. What is the ratio of the Emissions (1000 metric ton of CO2 equivalent) of France in 2008 to that in 2010?
Provide a succinct answer. 1.1. What is the ratio of the Emissions (1000 metric ton of CO2 equivalent) in Portugal in 2008 to that in 2010?
Offer a very short reply. 1.07. What is the ratio of the Emissions (1000 metric ton of CO2 equivalent) of United Arab Emirates in 2008 to that in 2010?
Provide a short and direct response. 0.35. What is the difference between the highest and the second highest Emissions (1000 metric ton of CO2 equivalent) of Ecuador?
Your response must be concise. 742.1. What is the difference between the highest and the second highest Emissions (1000 metric ton of CO2 equivalent) in France?
Keep it short and to the point. 1930.3. What is the difference between the highest and the second highest Emissions (1000 metric ton of CO2 equivalent) in Portugal?
Provide a short and direct response. 105.1. What is the difference between the highest and the second highest Emissions (1000 metric ton of CO2 equivalent) in United Arab Emirates?
Your response must be concise. 932.5. What is the difference between the highest and the lowest Emissions (1000 metric ton of CO2 equivalent) in Ecuador?
Your answer should be very brief. 1902.1. What is the difference between the highest and the lowest Emissions (1000 metric ton of CO2 equivalent) of France?
Provide a succinct answer. 6479.5. What is the difference between the highest and the lowest Emissions (1000 metric ton of CO2 equivalent) in Portugal?
Your answer should be compact. 423.5. What is the difference between the highest and the lowest Emissions (1000 metric ton of CO2 equivalent) of United Arab Emirates?
Provide a succinct answer. 1228.2. 